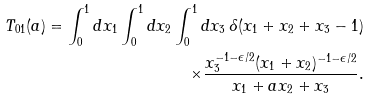Convert formula to latex. <formula><loc_0><loc_0><loc_500><loc_500>T _ { 0 1 } ( a ) = \int _ { 0 } ^ { 1 } d x _ { 1 } \int _ { 0 } ^ { 1 } d x _ { 2 } \int _ { 0 } ^ { 1 } d x _ { 3 } \, \delta ( x _ { 1 } + x _ { 2 } + x _ { 3 } - 1 ) \\ \times \frac { x ^ { - 1 - \epsilon / 2 } _ { 3 } ( x _ { 1 } + x _ { 2 } ) ^ { - 1 - \epsilon / 2 } } { x _ { 1 } + a x _ { 2 } + x _ { 3 } } .</formula> 